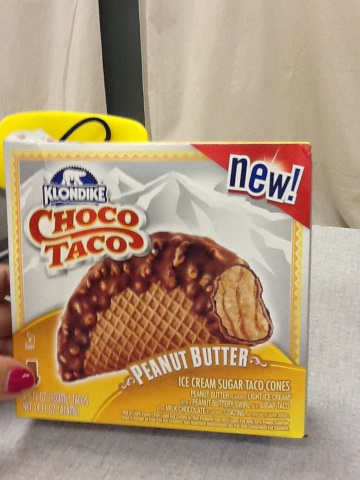What's unique about this ice cream product? The 'Choco Taco Peanut Butter' is unique because it combines the enjoyable shape of a taco with the delightful taste of ice cream. This variant includes the interesting twist of peanut butter flavor, which is not commonly found in ice cream tacos. 